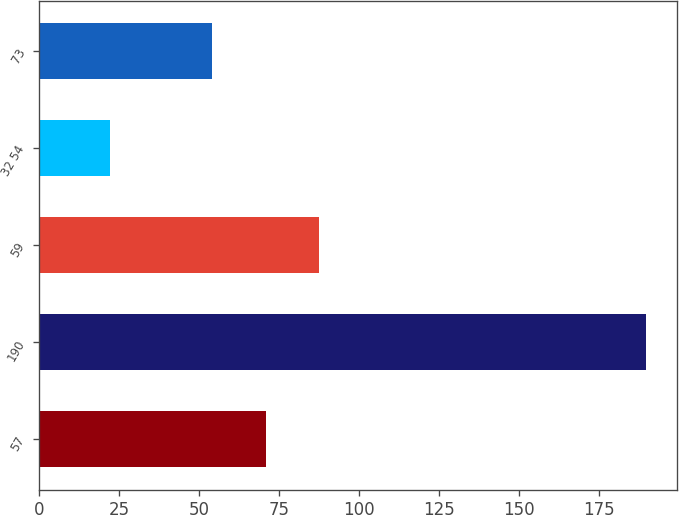Convert chart to OTSL. <chart><loc_0><loc_0><loc_500><loc_500><bar_chart><fcel>57<fcel>190<fcel>59<fcel>32 54<fcel>73<nl><fcel>70.8<fcel>190<fcel>87.6<fcel>22<fcel>54<nl></chart> 